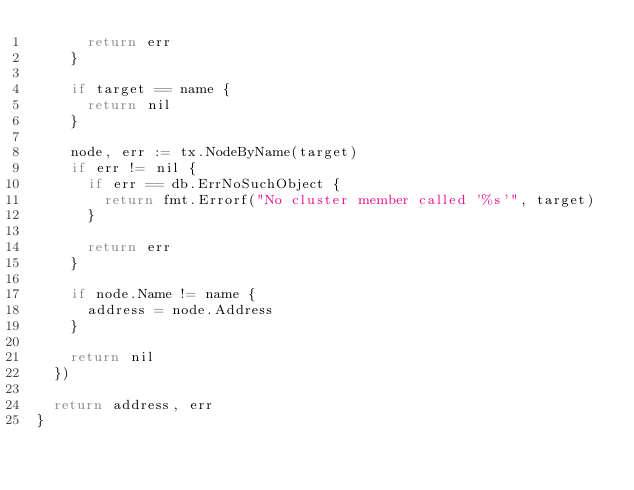Convert code to text. <code><loc_0><loc_0><loc_500><loc_500><_Go_>			return err
		}

		if target == name {
			return nil
		}

		node, err := tx.NodeByName(target)
		if err != nil {
			if err == db.ErrNoSuchObject {
				return fmt.Errorf("No cluster member called '%s'", target)
			}

			return err
		}

		if node.Name != name {
			address = node.Address
		}

		return nil
	})

	return address, err
}
</code> 